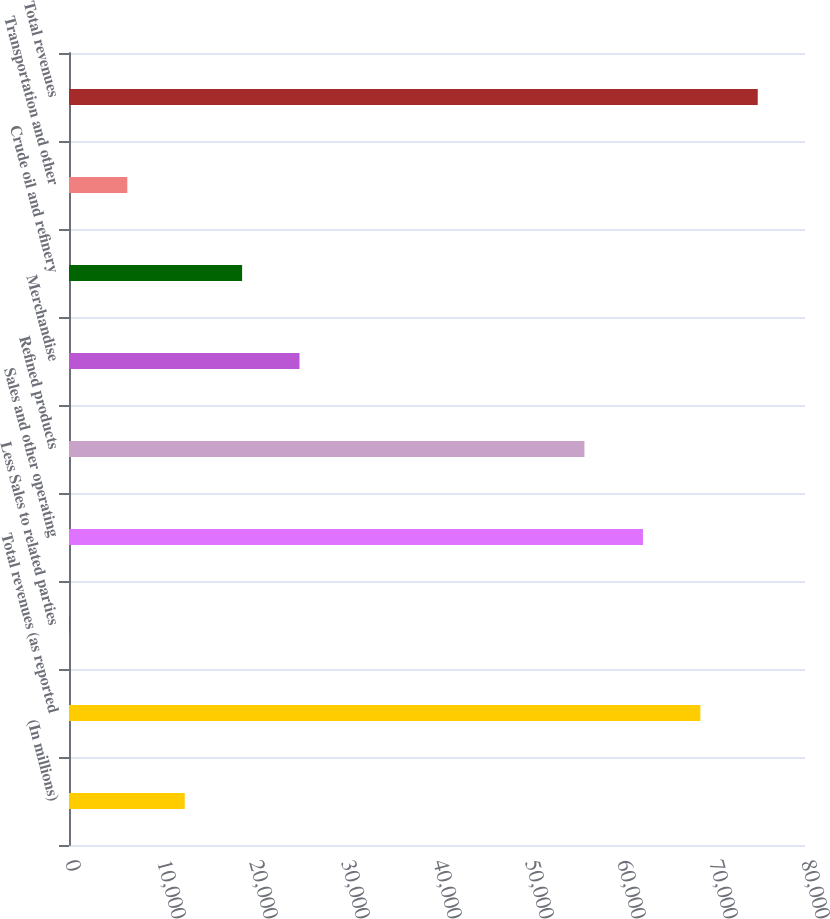<chart> <loc_0><loc_0><loc_500><loc_500><bar_chart><fcel>(In millions)<fcel>Total revenues (as reported<fcel>Less Sales to related parties<fcel>Sales and other operating<fcel>Refined products<fcel>Merchandise<fcel>Crude oil and refinery<fcel>Transportation and other<fcel>Total revenues<nl><fcel>12577.4<fcel>68625.7<fcel>100<fcel>62387<fcel>56025<fcel>25054.8<fcel>18816.1<fcel>6338.7<fcel>74864.4<nl></chart> 